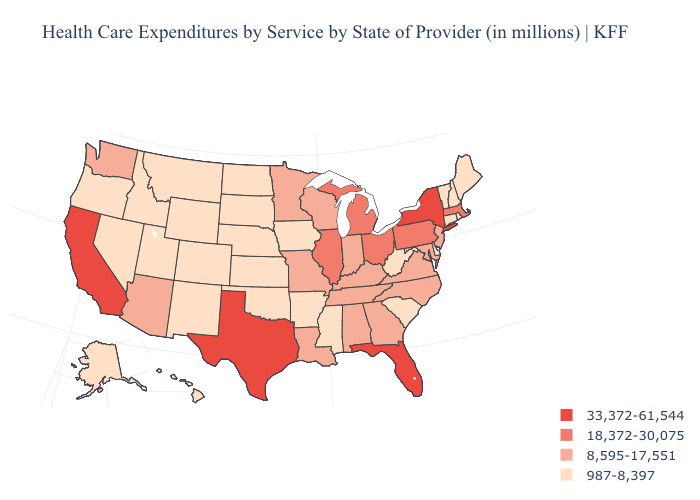What is the lowest value in states that border Ohio?
Concise answer only. 987-8,397. How many symbols are there in the legend?
Answer briefly. 4. What is the highest value in states that border Colorado?
Be succinct. 8,595-17,551. What is the highest value in states that border Nebraska?
Quick response, please. 8,595-17,551. What is the highest value in the USA?
Concise answer only. 33,372-61,544. Is the legend a continuous bar?
Answer briefly. No. Among the states that border North Carolina , which have the highest value?
Write a very short answer. Georgia, Tennessee, Virginia. Among the states that border Illinois , does Indiana have the lowest value?
Short answer required. No. What is the lowest value in states that border Vermont?
Quick response, please. 987-8,397. What is the value of Pennsylvania?
Be succinct. 18,372-30,075. What is the highest value in the USA?
Keep it brief. 33,372-61,544. Which states have the lowest value in the USA?
Be succinct. Alaska, Arkansas, Colorado, Connecticut, Delaware, Hawaii, Idaho, Iowa, Kansas, Maine, Mississippi, Montana, Nebraska, Nevada, New Hampshire, New Mexico, North Dakota, Oklahoma, Oregon, Rhode Island, South Carolina, South Dakota, Utah, Vermont, West Virginia, Wyoming. Does the first symbol in the legend represent the smallest category?
Write a very short answer. No. What is the value of Colorado?
Give a very brief answer. 987-8,397. Name the states that have a value in the range 18,372-30,075?
Answer briefly. Illinois, Massachusetts, Michigan, Ohio, Pennsylvania. 